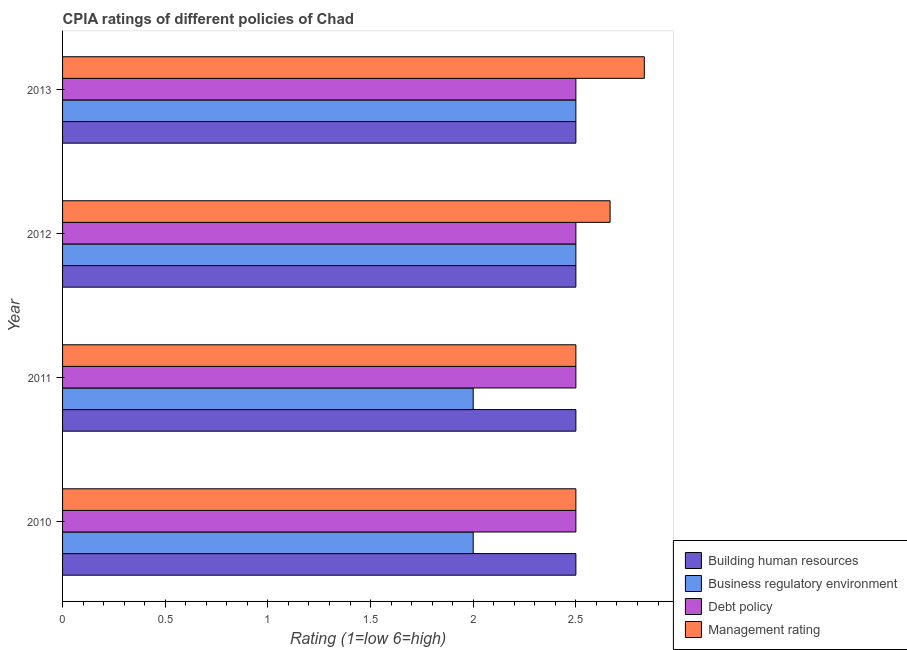How many groups of bars are there?
Offer a terse response. 4. Are the number of bars on each tick of the Y-axis equal?
Make the answer very short. Yes. How many bars are there on the 4th tick from the top?
Ensure brevity in your answer.  4. In how many cases, is the number of bars for a given year not equal to the number of legend labels?
Offer a very short reply. 0. What is the cpia rating of building human resources in 2013?
Ensure brevity in your answer.  2.5. Across all years, what is the maximum cpia rating of management?
Offer a very short reply. 2.83. In which year was the cpia rating of business regulatory environment minimum?
Your response must be concise. 2010. What is the difference between the cpia rating of building human resources in 2010 and the cpia rating of debt policy in 2011?
Provide a short and direct response. 0. What is the average cpia rating of business regulatory environment per year?
Your answer should be compact. 2.25. In the year 2013, what is the difference between the cpia rating of business regulatory environment and cpia rating of management?
Ensure brevity in your answer.  -0.33. In how many years, is the cpia rating of building human resources greater than 1.5 ?
Keep it short and to the point. 4. What is the ratio of the cpia rating of management in 2011 to that in 2012?
Offer a terse response. 0.94. What is the difference between the highest and the second highest cpia rating of management?
Offer a very short reply. 0.17. Is the sum of the cpia rating of business regulatory environment in 2011 and 2012 greater than the maximum cpia rating of building human resources across all years?
Provide a succinct answer. Yes. Is it the case that in every year, the sum of the cpia rating of management and cpia rating of debt policy is greater than the sum of cpia rating of building human resources and cpia rating of business regulatory environment?
Give a very brief answer. No. What does the 1st bar from the top in 2010 represents?
Ensure brevity in your answer.  Management rating. What does the 2nd bar from the bottom in 2012 represents?
Provide a short and direct response. Business regulatory environment. How many bars are there?
Offer a very short reply. 16. How many years are there in the graph?
Make the answer very short. 4. What is the difference between two consecutive major ticks on the X-axis?
Your response must be concise. 0.5. Are the values on the major ticks of X-axis written in scientific E-notation?
Offer a very short reply. No. Does the graph contain any zero values?
Keep it short and to the point. No. Where does the legend appear in the graph?
Offer a very short reply. Bottom right. How are the legend labels stacked?
Offer a very short reply. Vertical. What is the title of the graph?
Give a very brief answer. CPIA ratings of different policies of Chad. What is the label or title of the X-axis?
Your answer should be very brief. Rating (1=low 6=high). What is the Rating (1=low 6=high) in Building human resources in 2010?
Give a very brief answer. 2.5. What is the Rating (1=low 6=high) in Management rating in 2010?
Your answer should be very brief. 2.5. What is the Rating (1=low 6=high) of Building human resources in 2011?
Your answer should be very brief. 2.5. What is the Rating (1=low 6=high) of Business regulatory environment in 2011?
Your answer should be compact. 2. What is the Rating (1=low 6=high) in Management rating in 2011?
Provide a short and direct response. 2.5. What is the Rating (1=low 6=high) of Management rating in 2012?
Your answer should be compact. 2.67. What is the Rating (1=low 6=high) in Building human resources in 2013?
Provide a succinct answer. 2.5. What is the Rating (1=low 6=high) in Management rating in 2013?
Make the answer very short. 2.83. Across all years, what is the maximum Rating (1=low 6=high) in Debt policy?
Your response must be concise. 2.5. Across all years, what is the maximum Rating (1=low 6=high) in Management rating?
Provide a succinct answer. 2.83. Across all years, what is the minimum Rating (1=low 6=high) of Building human resources?
Offer a very short reply. 2.5. Across all years, what is the minimum Rating (1=low 6=high) of Management rating?
Provide a short and direct response. 2.5. What is the total Rating (1=low 6=high) in Building human resources in the graph?
Provide a succinct answer. 10. What is the total Rating (1=low 6=high) in Debt policy in the graph?
Your answer should be compact. 10. What is the total Rating (1=low 6=high) in Management rating in the graph?
Offer a terse response. 10.5. What is the difference between the Rating (1=low 6=high) of Business regulatory environment in 2010 and that in 2011?
Provide a short and direct response. 0. What is the difference between the Rating (1=low 6=high) in Building human resources in 2010 and that in 2012?
Offer a terse response. 0. What is the difference between the Rating (1=low 6=high) in Business regulatory environment in 2010 and that in 2012?
Your answer should be very brief. -0.5. What is the difference between the Rating (1=low 6=high) in Management rating in 2010 and that in 2012?
Provide a succinct answer. -0.17. What is the difference between the Rating (1=low 6=high) of Building human resources in 2010 and that in 2013?
Offer a terse response. 0. What is the difference between the Rating (1=low 6=high) in Business regulatory environment in 2010 and that in 2013?
Offer a very short reply. -0.5. What is the difference between the Rating (1=low 6=high) of Business regulatory environment in 2011 and that in 2012?
Give a very brief answer. -0.5. What is the difference between the Rating (1=low 6=high) of Debt policy in 2011 and that in 2012?
Make the answer very short. 0. What is the difference between the Rating (1=low 6=high) in Building human resources in 2011 and that in 2013?
Offer a very short reply. 0. What is the difference between the Rating (1=low 6=high) of Business regulatory environment in 2012 and that in 2013?
Provide a succinct answer. 0. What is the difference between the Rating (1=low 6=high) in Building human resources in 2010 and the Rating (1=low 6=high) in Management rating in 2011?
Offer a very short reply. 0. What is the difference between the Rating (1=low 6=high) of Business regulatory environment in 2010 and the Rating (1=low 6=high) of Debt policy in 2011?
Provide a short and direct response. -0.5. What is the difference between the Rating (1=low 6=high) in Business regulatory environment in 2010 and the Rating (1=low 6=high) in Management rating in 2011?
Offer a terse response. -0.5. What is the difference between the Rating (1=low 6=high) in Building human resources in 2010 and the Rating (1=low 6=high) in Business regulatory environment in 2012?
Your answer should be very brief. 0. What is the difference between the Rating (1=low 6=high) in Building human resources in 2010 and the Rating (1=low 6=high) in Debt policy in 2012?
Your response must be concise. 0. What is the difference between the Rating (1=low 6=high) of Building human resources in 2010 and the Rating (1=low 6=high) of Debt policy in 2013?
Your answer should be very brief. 0. What is the difference between the Rating (1=low 6=high) in Building human resources in 2010 and the Rating (1=low 6=high) in Management rating in 2013?
Keep it short and to the point. -0.33. What is the difference between the Rating (1=low 6=high) in Business regulatory environment in 2010 and the Rating (1=low 6=high) in Management rating in 2013?
Keep it short and to the point. -0.83. What is the difference between the Rating (1=low 6=high) in Building human resources in 2011 and the Rating (1=low 6=high) in Debt policy in 2012?
Your answer should be compact. 0. What is the difference between the Rating (1=low 6=high) in Business regulatory environment in 2011 and the Rating (1=low 6=high) in Management rating in 2012?
Your response must be concise. -0.67. What is the difference between the Rating (1=low 6=high) in Debt policy in 2011 and the Rating (1=low 6=high) in Management rating in 2012?
Keep it short and to the point. -0.17. What is the difference between the Rating (1=low 6=high) in Building human resources in 2011 and the Rating (1=low 6=high) in Business regulatory environment in 2013?
Make the answer very short. 0. What is the difference between the Rating (1=low 6=high) of Building human resources in 2011 and the Rating (1=low 6=high) of Management rating in 2013?
Your answer should be compact. -0.33. What is the difference between the Rating (1=low 6=high) in Business regulatory environment in 2011 and the Rating (1=low 6=high) in Debt policy in 2013?
Make the answer very short. -0.5. What is the difference between the Rating (1=low 6=high) of Building human resources in 2012 and the Rating (1=low 6=high) of Debt policy in 2013?
Give a very brief answer. 0. What is the difference between the Rating (1=low 6=high) of Building human resources in 2012 and the Rating (1=low 6=high) of Management rating in 2013?
Provide a short and direct response. -0.33. What is the difference between the Rating (1=low 6=high) in Business regulatory environment in 2012 and the Rating (1=low 6=high) in Debt policy in 2013?
Your answer should be very brief. 0. What is the difference between the Rating (1=low 6=high) of Business regulatory environment in 2012 and the Rating (1=low 6=high) of Management rating in 2013?
Your answer should be compact. -0.33. What is the average Rating (1=low 6=high) in Business regulatory environment per year?
Provide a short and direct response. 2.25. What is the average Rating (1=low 6=high) in Debt policy per year?
Provide a short and direct response. 2.5. What is the average Rating (1=low 6=high) of Management rating per year?
Keep it short and to the point. 2.62. In the year 2010, what is the difference between the Rating (1=low 6=high) in Building human resources and Rating (1=low 6=high) in Debt policy?
Give a very brief answer. 0. In the year 2010, what is the difference between the Rating (1=low 6=high) in Business regulatory environment and Rating (1=low 6=high) in Debt policy?
Your answer should be compact. -0.5. In the year 2010, what is the difference between the Rating (1=low 6=high) of Business regulatory environment and Rating (1=low 6=high) of Management rating?
Make the answer very short. -0.5. In the year 2010, what is the difference between the Rating (1=low 6=high) in Debt policy and Rating (1=low 6=high) in Management rating?
Make the answer very short. 0. In the year 2011, what is the difference between the Rating (1=low 6=high) in Building human resources and Rating (1=low 6=high) in Business regulatory environment?
Provide a succinct answer. 0.5. In the year 2011, what is the difference between the Rating (1=low 6=high) of Building human resources and Rating (1=low 6=high) of Management rating?
Provide a succinct answer. 0. In the year 2012, what is the difference between the Rating (1=low 6=high) in Building human resources and Rating (1=low 6=high) in Business regulatory environment?
Provide a short and direct response. 0. In the year 2012, what is the difference between the Rating (1=low 6=high) in Building human resources and Rating (1=low 6=high) in Debt policy?
Offer a terse response. 0. In the year 2012, what is the difference between the Rating (1=low 6=high) of Building human resources and Rating (1=low 6=high) of Management rating?
Give a very brief answer. -0.17. In the year 2012, what is the difference between the Rating (1=low 6=high) in Business regulatory environment and Rating (1=low 6=high) in Management rating?
Provide a succinct answer. -0.17. In the year 2012, what is the difference between the Rating (1=low 6=high) of Debt policy and Rating (1=low 6=high) of Management rating?
Keep it short and to the point. -0.17. In the year 2013, what is the difference between the Rating (1=low 6=high) of Building human resources and Rating (1=low 6=high) of Business regulatory environment?
Make the answer very short. 0. What is the ratio of the Rating (1=low 6=high) in Building human resources in 2010 to that in 2011?
Provide a short and direct response. 1. What is the ratio of the Rating (1=low 6=high) in Business regulatory environment in 2010 to that in 2011?
Make the answer very short. 1. What is the ratio of the Rating (1=low 6=high) of Management rating in 2010 to that in 2011?
Offer a terse response. 1. What is the ratio of the Rating (1=low 6=high) of Building human resources in 2010 to that in 2012?
Your answer should be very brief. 1. What is the ratio of the Rating (1=low 6=high) of Business regulatory environment in 2010 to that in 2012?
Your answer should be compact. 0.8. What is the ratio of the Rating (1=low 6=high) of Debt policy in 2010 to that in 2012?
Offer a terse response. 1. What is the ratio of the Rating (1=low 6=high) in Management rating in 2010 to that in 2012?
Provide a short and direct response. 0.94. What is the ratio of the Rating (1=low 6=high) in Building human resources in 2010 to that in 2013?
Offer a very short reply. 1. What is the ratio of the Rating (1=low 6=high) in Management rating in 2010 to that in 2013?
Give a very brief answer. 0.88. What is the ratio of the Rating (1=low 6=high) in Business regulatory environment in 2011 to that in 2012?
Keep it short and to the point. 0.8. What is the ratio of the Rating (1=low 6=high) of Business regulatory environment in 2011 to that in 2013?
Ensure brevity in your answer.  0.8. What is the ratio of the Rating (1=low 6=high) in Debt policy in 2011 to that in 2013?
Your response must be concise. 1. What is the ratio of the Rating (1=low 6=high) in Management rating in 2011 to that in 2013?
Ensure brevity in your answer.  0.88. What is the ratio of the Rating (1=low 6=high) in Debt policy in 2012 to that in 2013?
Your response must be concise. 1. What is the ratio of the Rating (1=low 6=high) in Management rating in 2012 to that in 2013?
Keep it short and to the point. 0.94. What is the difference between the highest and the second highest Rating (1=low 6=high) in Building human resources?
Provide a short and direct response. 0. What is the difference between the highest and the second highest Rating (1=low 6=high) in Debt policy?
Make the answer very short. 0. What is the difference between the highest and the lowest Rating (1=low 6=high) of Building human resources?
Provide a short and direct response. 0. 